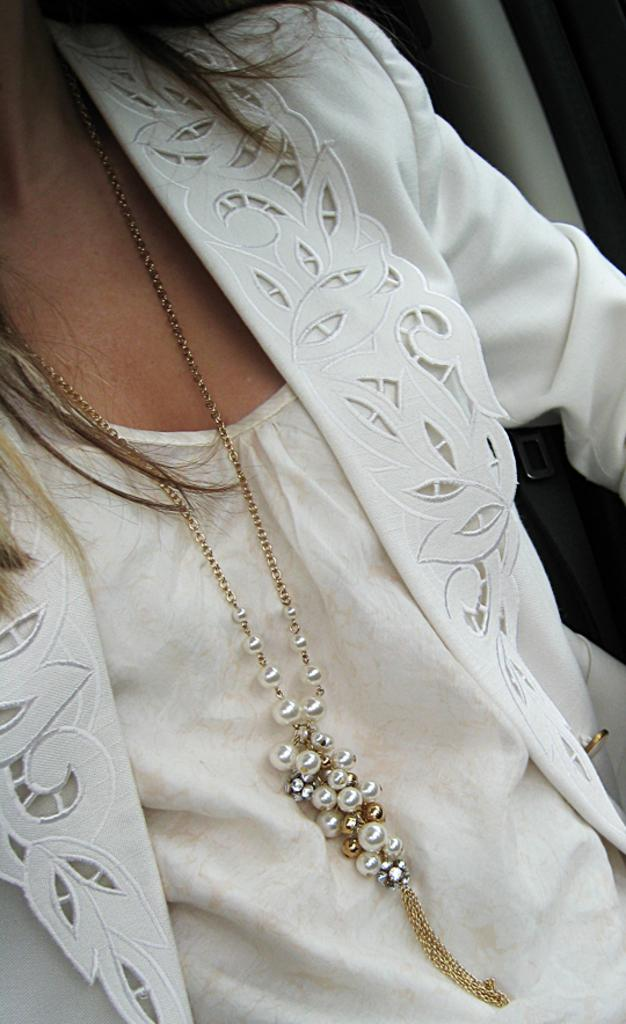Who or what is present in the image? There is a person in the image. What is the person wearing? The person is wearing a cream-colored dress. Are there any accessories visible on the person? Yes, the person is wearing a chain. What can be seen in the background of the image? There is a grey-colored object in the background of the image. How many apples are hanging from the chain around the person's neck? There are no apples present in the image, nor are they hanging from the chain. 